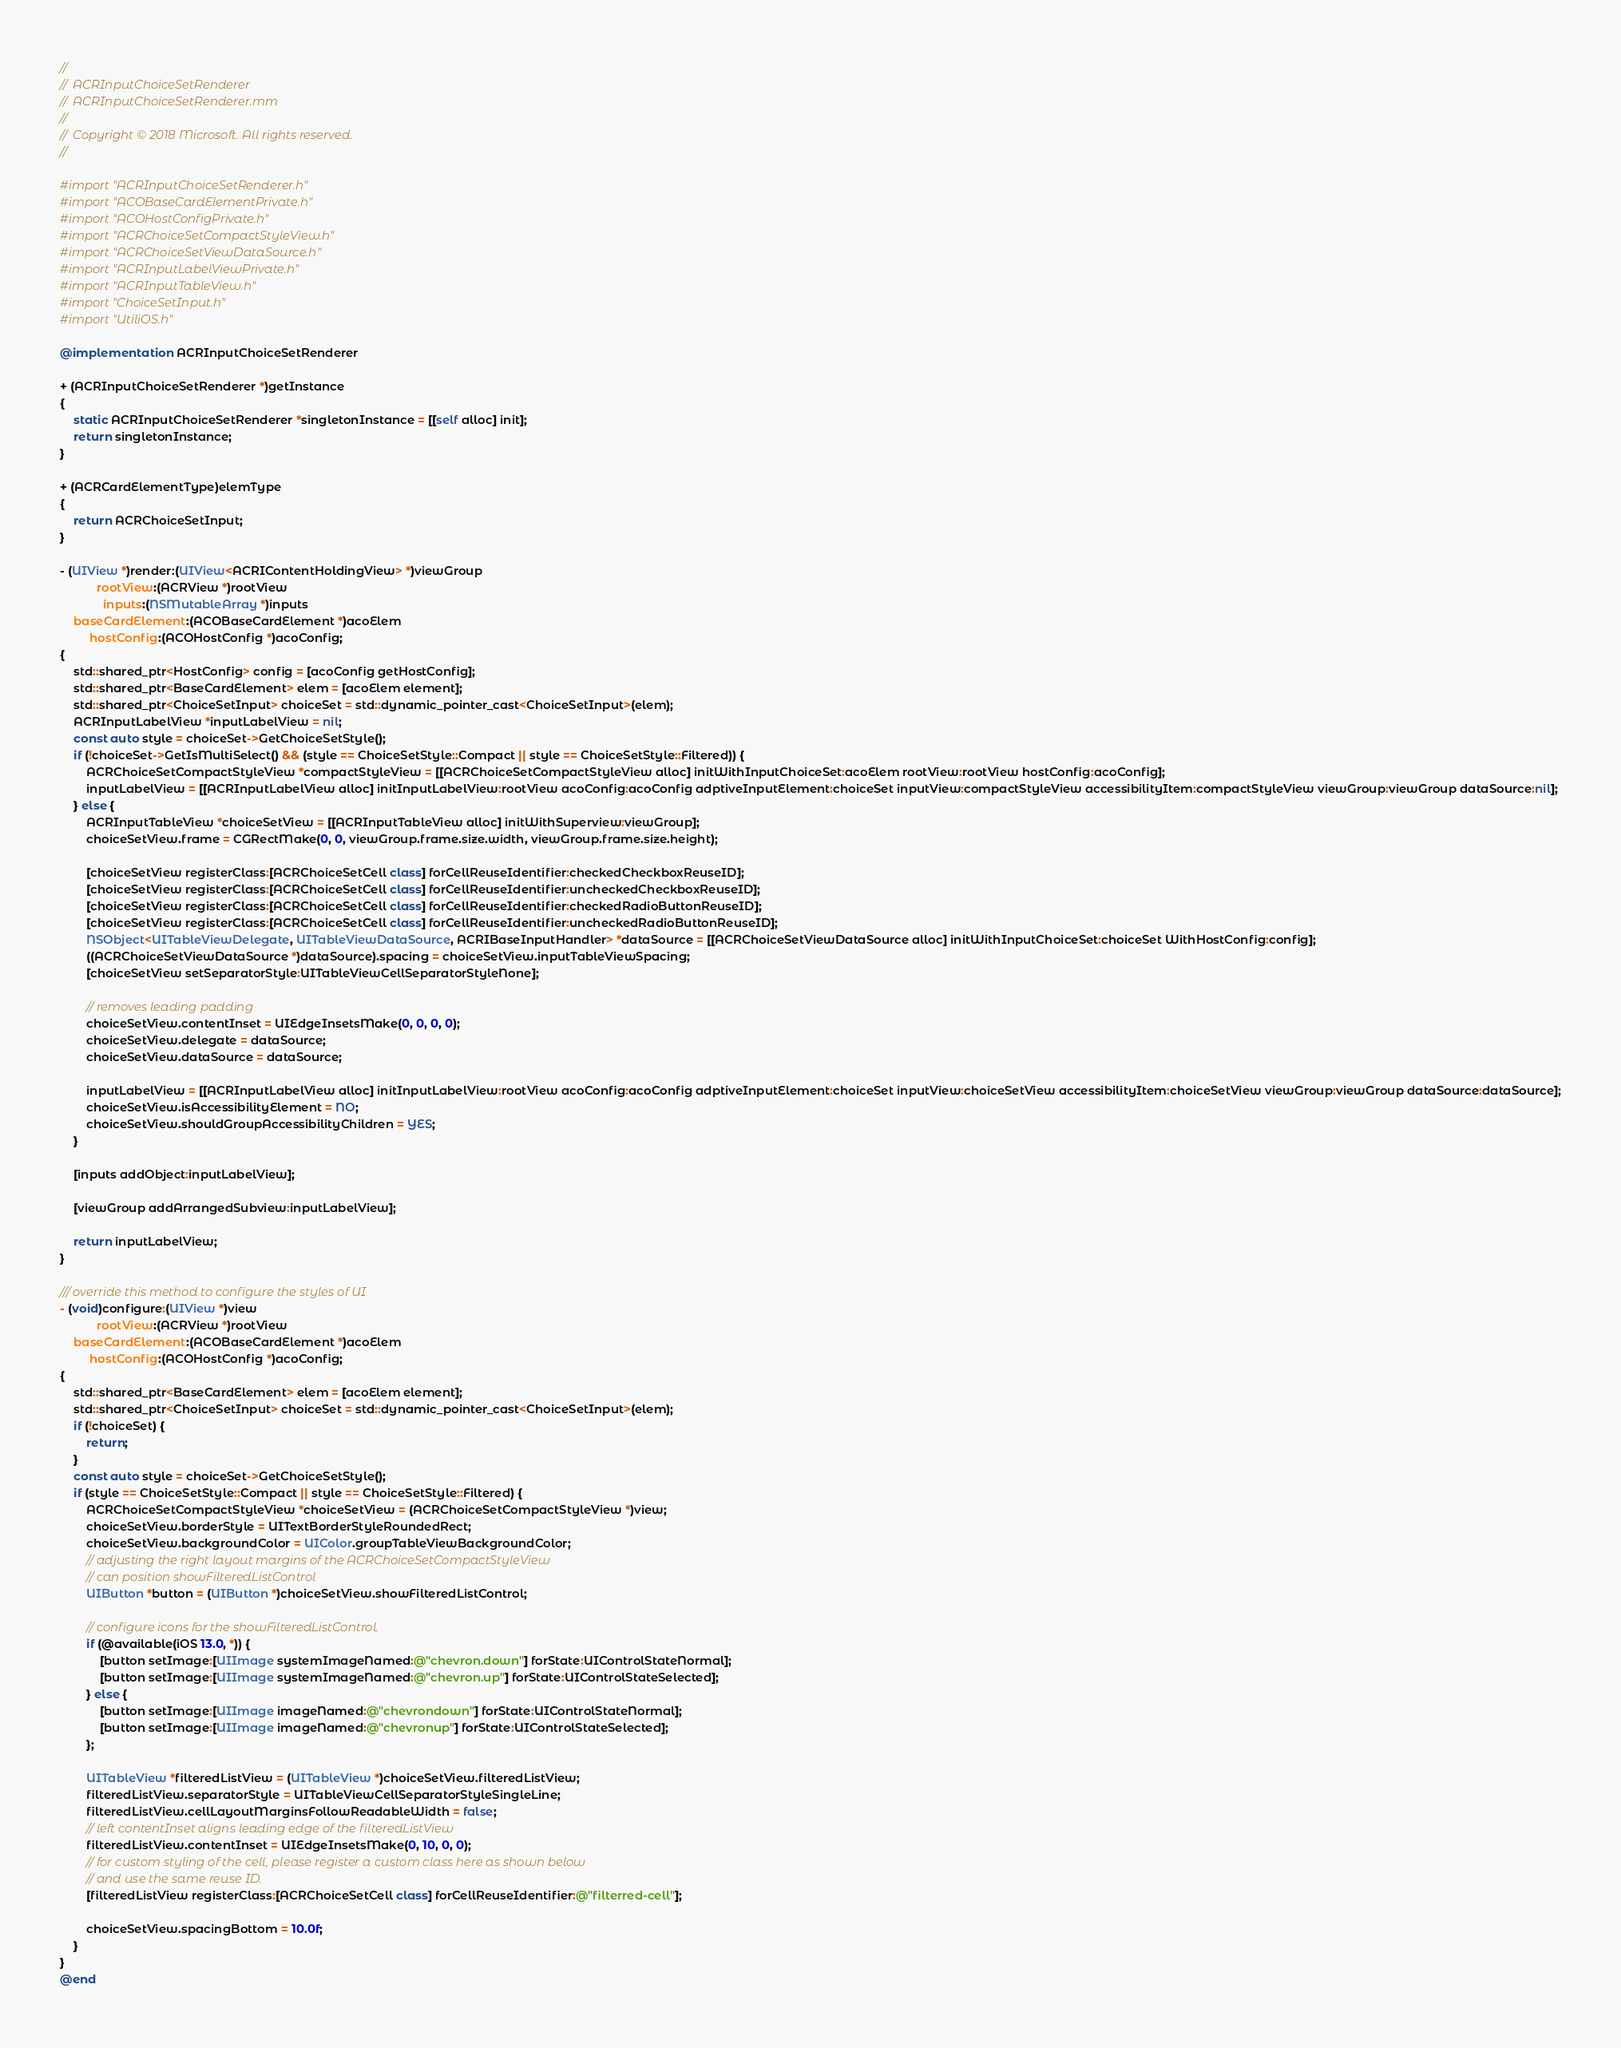<code> <loc_0><loc_0><loc_500><loc_500><_ObjectiveC_>//
//  ACRInputChoiceSetRenderer
//  ACRInputChoiceSetRenderer.mm
//
//  Copyright © 2018 Microsoft. All rights reserved.
//

#import "ACRInputChoiceSetRenderer.h"
#import "ACOBaseCardElementPrivate.h"
#import "ACOHostConfigPrivate.h"
#import "ACRChoiceSetCompactStyleView.h"
#import "ACRChoiceSetViewDataSource.h"
#import "ACRInputLabelViewPrivate.h"
#import "ACRInputTableView.h"
#import "ChoiceSetInput.h"
#import "UtiliOS.h"

@implementation ACRInputChoiceSetRenderer

+ (ACRInputChoiceSetRenderer *)getInstance
{
    static ACRInputChoiceSetRenderer *singletonInstance = [[self alloc] init];
    return singletonInstance;
}

+ (ACRCardElementType)elemType
{
    return ACRChoiceSetInput;
}

- (UIView *)render:(UIView<ACRIContentHoldingView> *)viewGroup
           rootView:(ACRView *)rootView
             inputs:(NSMutableArray *)inputs
    baseCardElement:(ACOBaseCardElement *)acoElem
         hostConfig:(ACOHostConfig *)acoConfig;
{
    std::shared_ptr<HostConfig> config = [acoConfig getHostConfig];
    std::shared_ptr<BaseCardElement> elem = [acoElem element];
    std::shared_ptr<ChoiceSetInput> choiceSet = std::dynamic_pointer_cast<ChoiceSetInput>(elem);
    ACRInputLabelView *inputLabelView = nil;
    const auto style = choiceSet->GetChoiceSetStyle();
    if (!choiceSet->GetIsMultiSelect() && (style == ChoiceSetStyle::Compact || style == ChoiceSetStyle::Filtered)) {
        ACRChoiceSetCompactStyleView *compactStyleView = [[ACRChoiceSetCompactStyleView alloc] initWithInputChoiceSet:acoElem rootView:rootView hostConfig:acoConfig];
        inputLabelView = [[ACRInputLabelView alloc] initInputLabelView:rootView acoConfig:acoConfig adptiveInputElement:choiceSet inputView:compactStyleView accessibilityItem:compactStyleView viewGroup:viewGroup dataSource:nil];
    } else {
        ACRInputTableView *choiceSetView = [[ACRInputTableView alloc] initWithSuperview:viewGroup];
        choiceSetView.frame = CGRectMake(0, 0, viewGroup.frame.size.width, viewGroup.frame.size.height);

        [choiceSetView registerClass:[ACRChoiceSetCell class] forCellReuseIdentifier:checkedCheckboxReuseID];
        [choiceSetView registerClass:[ACRChoiceSetCell class] forCellReuseIdentifier:uncheckedCheckboxReuseID];
        [choiceSetView registerClass:[ACRChoiceSetCell class] forCellReuseIdentifier:checkedRadioButtonReuseID];
        [choiceSetView registerClass:[ACRChoiceSetCell class] forCellReuseIdentifier:uncheckedRadioButtonReuseID];
        NSObject<UITableViewDelegate, UITableViewDataSource, ACRIBaseInputHandler> *dataSource = [[ACRChoiceSetViewDataSource alloc] initWithInputChoiceSet:choiceSet WithHostConfig:config];
        ((ACRChoiceSetViewDataSource *)dataSource).spacing = choiceSetView.inputTableViewSpacing;
        [choiceSetView setSeparatorStyle:UITableViewCellSeparatorStyleNone];

        // removes leading padding
        choiceSetView.contentInset = UIEdgeInsetsMake(0, 0, 0, 0);
        choiceSetView.delegate = dataSource;
        choiceSetView.dataSource = dataSource;

        inputLabelView = [[ACRInputLabelView alloc] initInputLabelView:rootView acoConfig:acoConfig adptiveInputElement:choiceSet inputView:choiceSetView accessibilityItem:choiceSetView viewGroup:viewGroup dataSource:dataSource];
        choiceSetView.isAccessibilityElement = NO;
        choiceSetView.shouldGroupAccessibilityChildren = YES;
    }

    [inputs addObject:inputLabelView];

    [viewGroup addArrangedSubview:inputLabelView];

    return inputLabelView;
}

/// override this method to configure the styles of UI
- (void)configure:(UIView *)view
           rootView:(ACRView *)rootView
    baseCardElement:(ACOBaseCardElement *)acoElem
         hostConfig:(ACOHostConfig *)acoConfig;
{
    std::shared_ptr<BaseCardElement> elem = [acoElem element];
    std::shared_ptr<ChoiceSetInput> choiceSet = std::dynamic_pointer_cast<ChoiceSetInput>(elem);
    if (!choiceSet) {
        return;
    }
    const auto style = choiceSet->GetChoiceSetStyle();
    if (style == ChoiceSetStyle::Compact || style == ChoiceSetStyle::Filtered) {
        ACRChoiceSetCompactStyleView *choiceSetView = (ACRChoiceSetCompactStyleView *)view;
        choiceSetView.borderStyle = UITextBorderStyleRoundedRect;
        choiceSetView.backgroundColor = UIColor.groupTableViewBackgroundColor;
        // adjusting the right layout margins of the ACRChoiceSetCompactStyleView
        // can position showFilteredListControl
        UIButton *button = (UIButton *)choiceSetView.showFilteredListControl;

        // configure icons for the showFilteredListControl.
        if (@available(iOS 13.0, *)) {
            [button setImage:[UIImage systemImageNamed:@"chevron.down"] forState:UIControlStateNormal];
            [button setImage:[UIImage systemImageNamed:@"chevron.up"] forState:UIControlStateSelected];
        } else {
            [button setImage:[UIImage imageNamed:@"chevrondown"] forState:UIControlStateNormal];
            [button setImage:[UIImage imageNamed:@"chevronup"] forState:UIControlStateSelected];
        };

        UITableView *filteredListView = (UITableView *)choiceSetView.filteredListView;
        filteredListView.separatorStyle = UITableViewCellSeparatorStyleSingleLine;
        filteredListView.cellLayoutMarginsFollowReadableWidth = false;
        // left contentInset aligns leading edge of the filteredListView
        filteredListView.contentInset = UIEdgeInsetsMake(0, 10, 0, 0);
        // for custom styling of the cell, please register a custom class here as shown below
        // and use the same reuse ID.
        [filteredListView registerClass:[ACRChoiceSetCell class] forCellReuseIdentifier:@"filterred-cell"];

        choiceSetView.spacingBottom = 10.0f;
    }
}
@end
</code> 